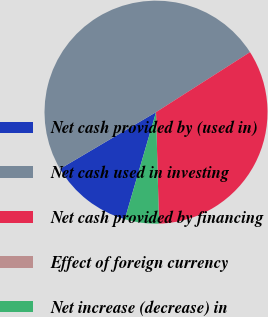Convert chart to OTSL. <chart><loc_0><loc_0><loc_500><loc_500><pie_chart><fcel>Net cash provided by (used in)<fcel>Net cash used in investing<fcel>Net cash provided by financing<fcel>Effect of foreign currency<fcel>Net increase (decrease) in<nl><fcel>12.0%<fcel>49.44%<fcel>33.62%<fcel>0.0%<fcel>4.94%<nl></chart> 